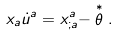<formula> <loc_0><loc_0><loc_500><loc_500>x _ { a } \dot { u } ^ { a } = x ^ { a } _ { ; a } - \stackrel { * } \theta .</formula> 